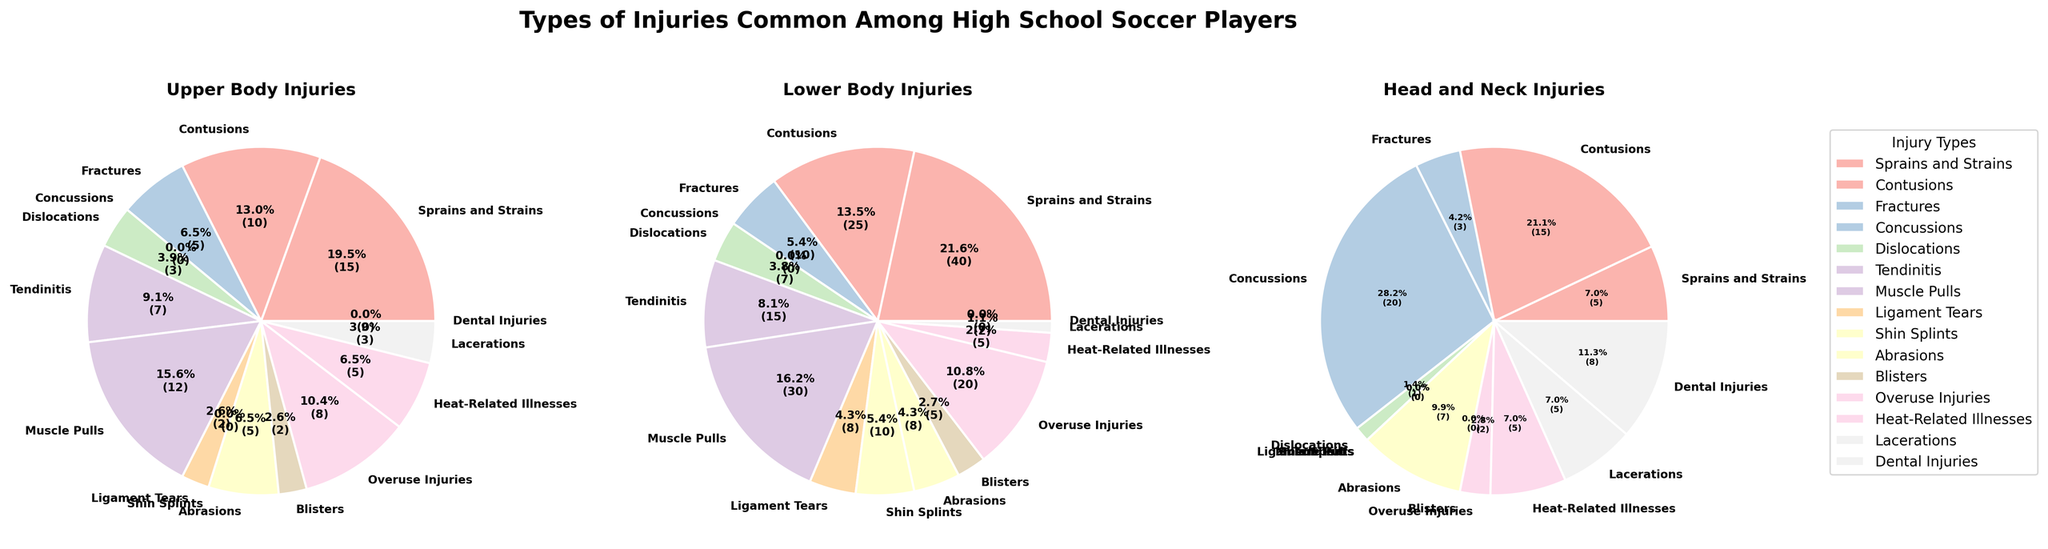What is the most common type of injury for Lower Body Injuries? First, examine the pie chart labeled 'Lower Body Injuries'. Look at the segment whose percentage is highest. This segment represents the most common type of injury.
Answer: Sprains and Strains Which injury is more prevalent in Lower Body Injuries compared to Upper Body Injuries? Compare the percentages of various injuries between the charts for Upper Body and Lower Body Injuries. Find an injury type that has a higher percentage in Lower Body Injuries.
Answer: Sprains and Strains Are there any injury types unique to Head and Neck Injuries? View the Head and Neck Injuries pie chart and identify any injury types that have a percentage present in this chart only and not in either of the other two.
Answer: Concussions, Dental Injuries What percentage of Upper Body Injuries are due to Abrasions? Locate the segment for abrasions in the Upper Body Injuries pie chart and read the percentage label.
Answer: 5.9% Compare the prevalence of Concussions in Head and Neck Injuries with other injuries in the same category. In the Head and Neck Injuries pie chart, identify the percentage for Concussions and compare it with that of other injury types.
Answer: Highest (50%) Which pie chart segment represents the smallest percentage in Lower Body Injuries? Examine the Lower Body Injuries chart and locate the smallest segment by observing the percentage labels.
Answer: Ligament Tears How many types of injuries account for exactly zero percentage in Upper Body Injuries? Identify the segments in the Upper Body Injuries pie chart where the percentage is zero. Count these segments.
Answer: 1 (Dental Injuries) Among all injury types, which one appears more frequent in all three categories (Upper, Lower, Head/Neck)? Analyze all three pie charts and find the injury type that is present in all three categories with significant percentages.
Answer: Contusions Out of the total types of injuries for Lower Body Injuries, what is the total percentage for Heat-Related Illnesses and Overuse Injuries combined? Find the percentages for Heat-Related Illnesses and Overuse Injuries in the Lower Body Injuries pie chart and sum these values together.
Answer: 12.5% + 25% = 37.5% What percentage of Lower Body Injuries are due to Tendinitis, and how does it compare to its share in Upper Body Injuries? Locate Tendinitis in both the Lower Body and Upper Body charts, then compare their percentages.
Answer: Lower: 18.8%, Upper: 13.5% 